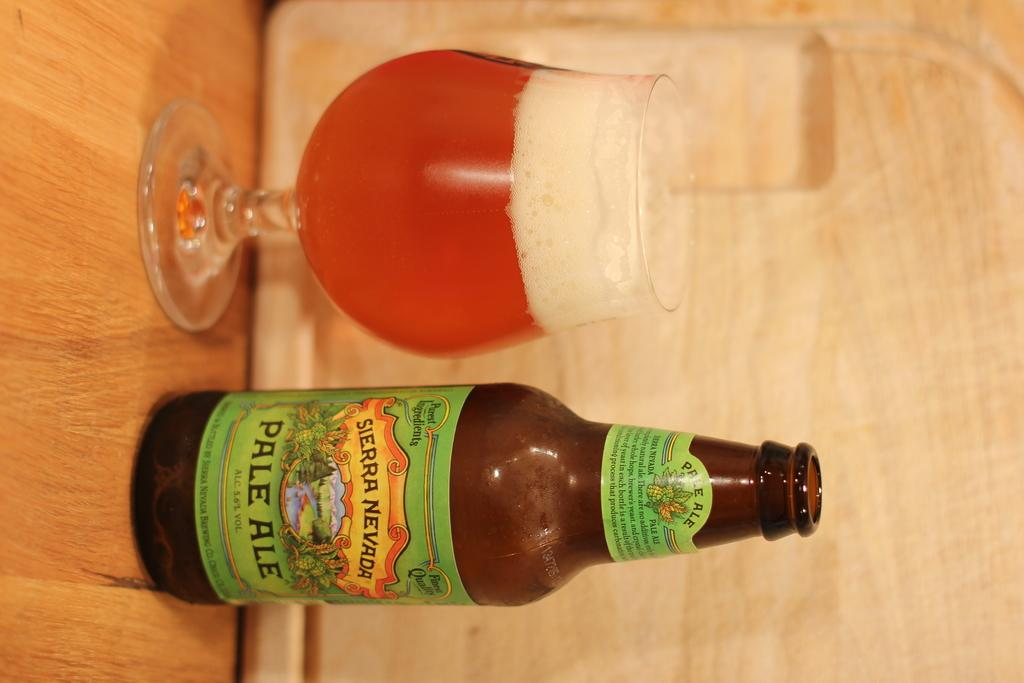<image>
Render a clear and concise summary of the photo. Sierra Neveda Pale Ale bottle next to a full beer glass on a wooden table. 